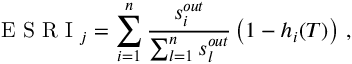<formula> <loc_0><loc_0><loc_500><loc_500>E S R I _ { j } = \sum _ { i = 1 } ^ { n } { \frac { s _ { i } ^ { o u t } } { \sum _ { l = 1 } ^ { n } { s _ { l } ^ { o u t } } } } \left ( 1 - h _ { i } ( T ) \right ) \, ,</formula> 